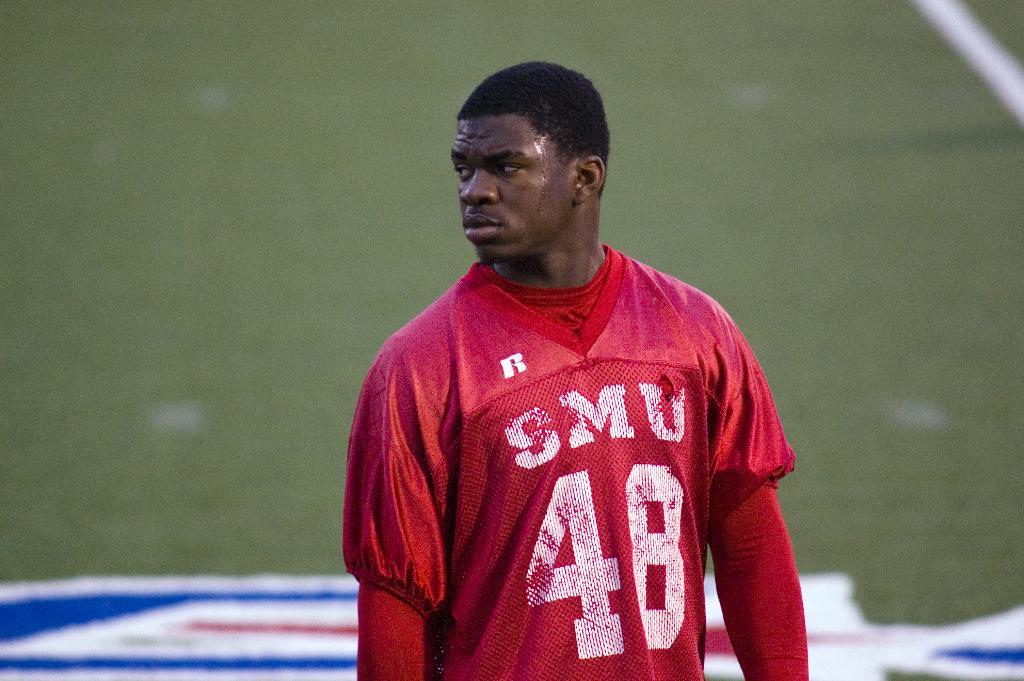What is his jersey number?
Provide a succinct answer. 48. 